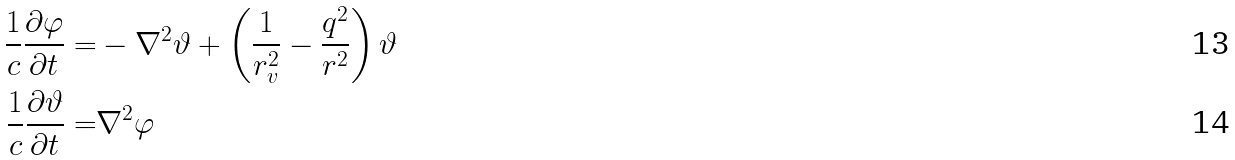Convert formula to latex. <formula><loc_0><loc_0><loc_500><loc_500>\frac { 1 } { c } \frac { \partial \varphi } { \partial t } = & - \nabla ^ { 2 } \vartheta + \left ( \frac { 1 } { r _ { v } ^ { 2 } } - \frac { q ^ { 2 } } { r ^ { 2 } } \right ) \vartheta \\ \frac { 1 } { c } \frac { \partial \vartheta } { \partial t } = & \nabla ^ { 2 } \varphi</formula> 